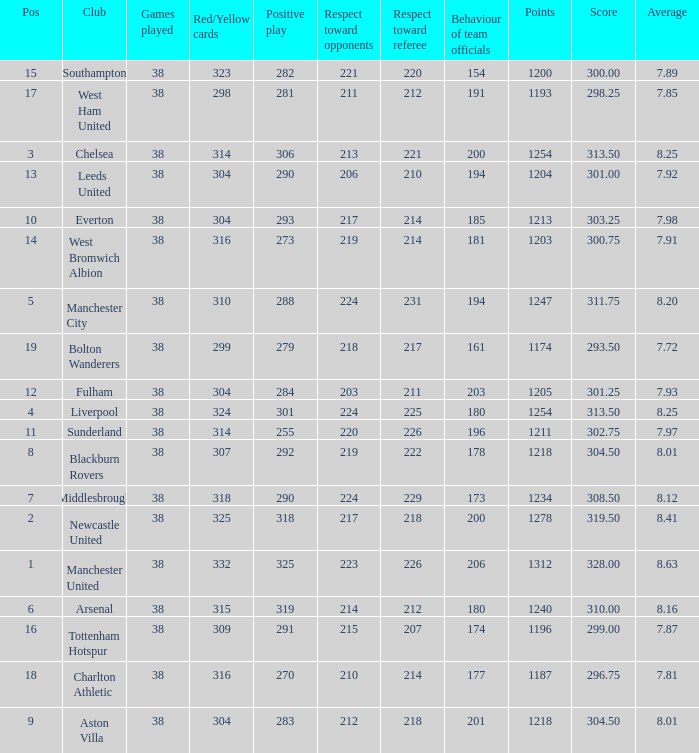Name the pos for west ham united 17.0. 